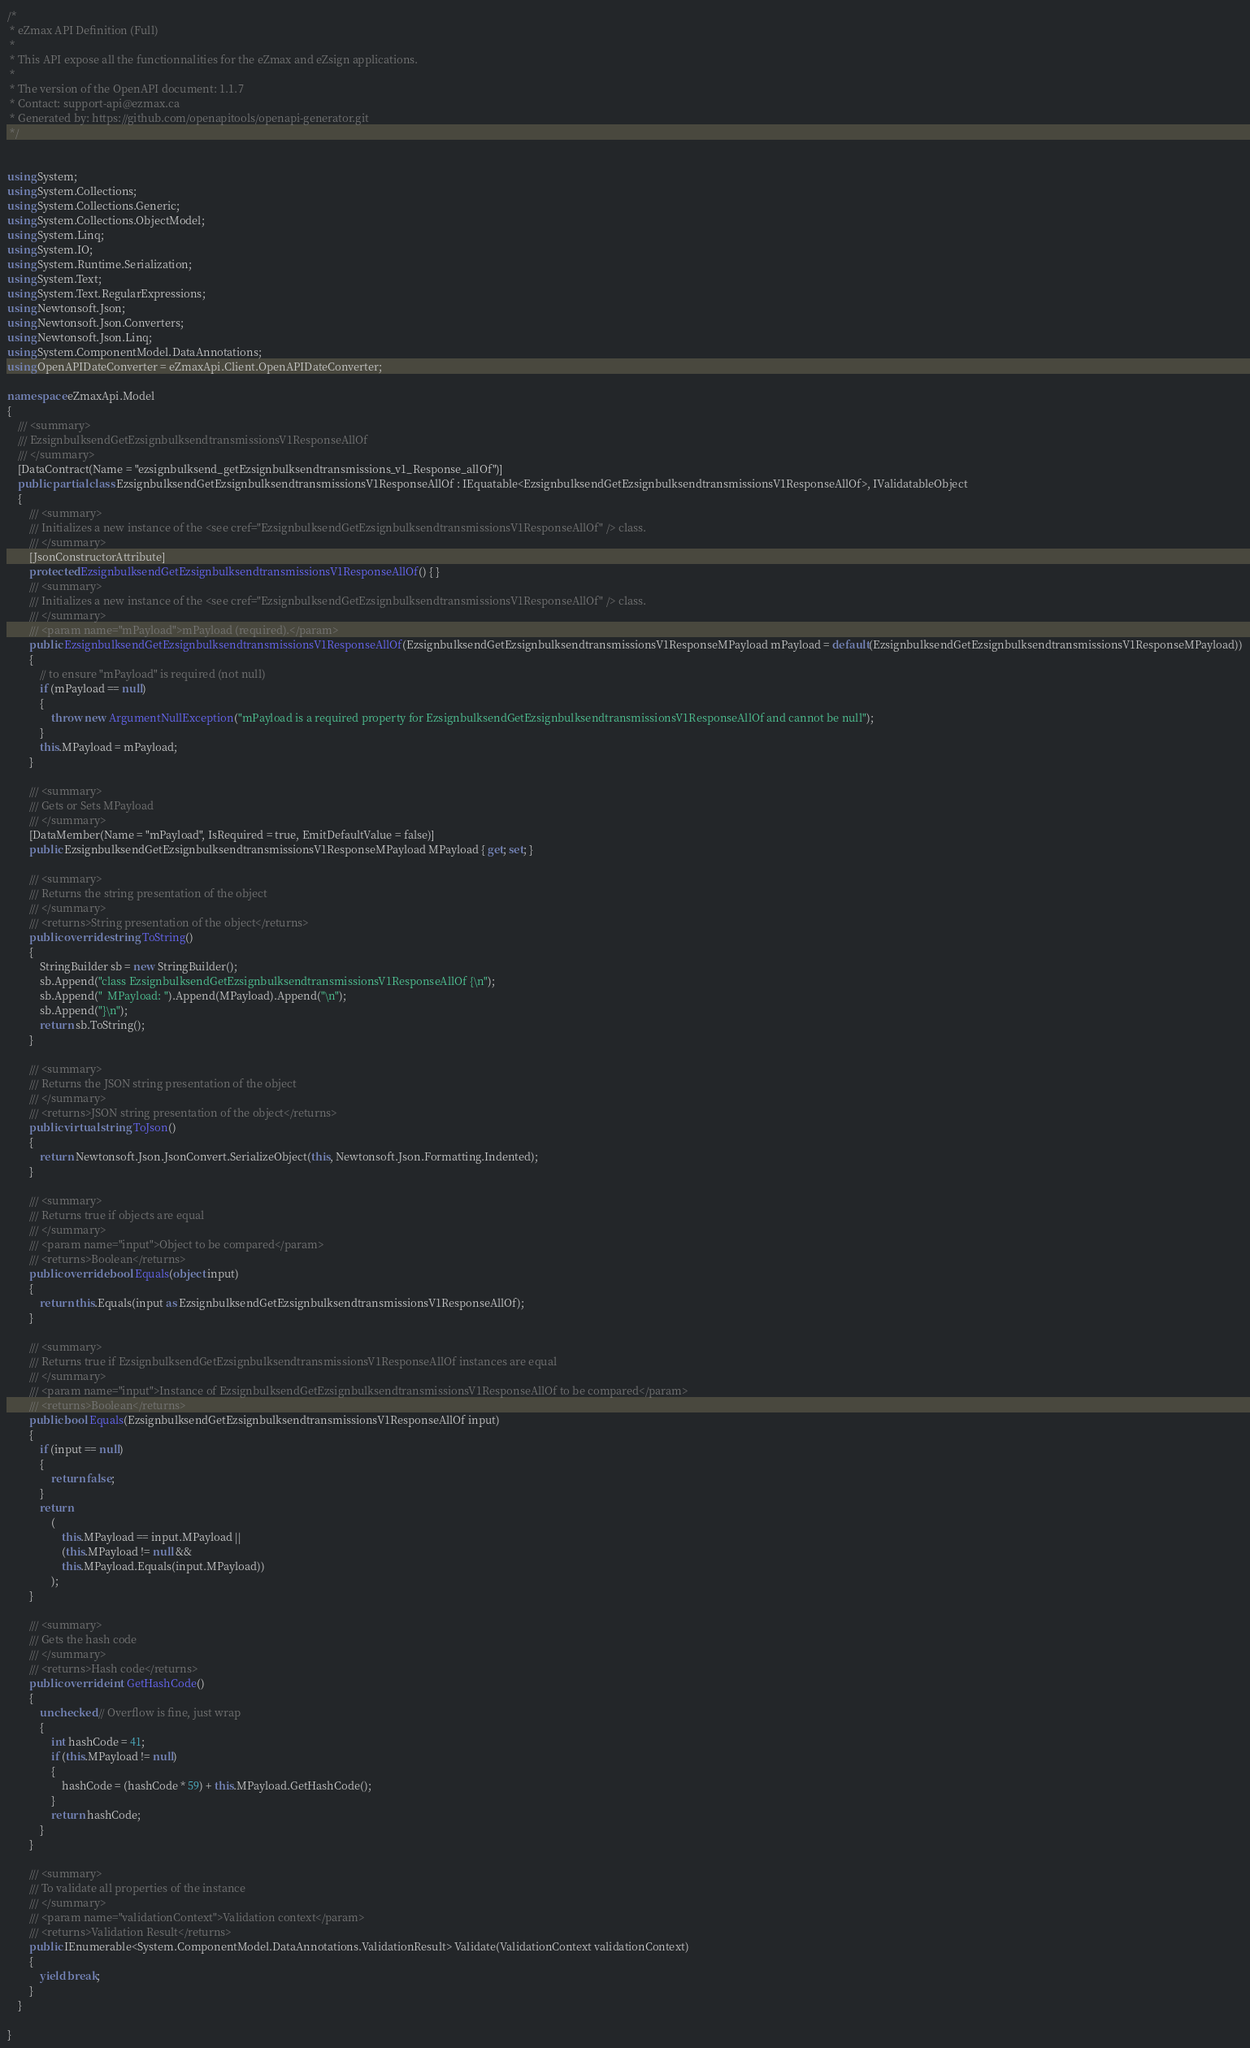Convert code to text. <code><loc_0><loc_0><loc_500><loc_500><_C#_>/*
 * eZmax API Definition (Full)
 *
 * This API expose all the functionnalities for the eZmax and eZsign applications.
 *
 * The version of the OpenAPI document: 1.1.7
 * Contact: support-api@ezmax.ca
 * Generated by: https://github.com/openapitools/openapi-generator.git
 */


using System;
using System.Collections;
using System.Collections.Generic;
using System.Collections.ObjectModel;
using System.Linq;
using System.IO;
using System.Runtime.Serialization;
using System.Text;
using System.Text.RegularExpressions;
using Newtonsoft.Json;
using Newtonsoft.Json.Converters;
using Newtonsoft.Json.Linq;
using System.ComponentModel.DataAnnotations;
using OpenAPIDateConverter = eZmaxApi.Client.OpenAPIDateConverter;

namespace eZmaxApi.Model
{
    /// <summary>
    /// EzsignbulksendGetEzsignbulksendtransmissionsV1ResponseAllOf
    /// </summary>
    [DataContract(Name = "ezsignbulksend_getEzsignbulksendtransmissions_v1_Response_allOf")]
    public partial class EzsignbulksendGetEzsignbulksendtransmissionsV1ResponseAllOf : IEquatable<EzsignbulksendGetEzsignbulksendtransmissionsV1ResponseAllOf>, IValidatableObject
    {
        /// <summary>
        /// Initializes a new instance of the <see cref="EzsignbulksendGetEzsignbulksendtransmissionsV1ResponseAllOf" /> class.
        /// </summary>
        [JsonConstructorAttribute]
        protected EzsignbulksendGetEzsignbulksendtransmissionsV1ResponseAllOf() { }
        /// <summary>
        /// Initializes a new instance of the <see cref="EzsignbulksendGetEzsignbulksendtransmissionsV1ResponseAllOf" /> class.
        /// </summary>
        /// <param name="mPayload">mPayload (required).</param>
        public EzsignbulksendGetEzsignbulksendtransmissionsV1ResponseAllOf(EzsignbulksendGetEzsignbulksendtransmissionsV1ResponseMPayload mPayload = default(EzsignbulksendGetEzsignbulksendtransmissionsV1ResponseMPayload))
        {
            // to ensure "mPayload" is required (not null)
            if (mPayload == null)
            {
                throw new ArgumentNullException("mPayload is a required property for EzsignbulksendGetEzsignbulksendtransmissionsV1ResponseAllOf and cannot be null");
            }
            this.MPayload = mPayload;
        }

        /// <summary>
        /// Gets or Sets MPayload
        /// </summary>
        [DataMember(Name = "mPayload", IsRequired = true, EmitDefaultValue = false)]
        public EzsignbulksendGetEzsignbulksendtransmissionsV1ResponseMPayload MPayload { get; set; }

        /// <summary>
        /// Returns the string presentation of the object
        /// </summary>
        /// <returns>String presentation of the object</returns>
        public override string ToString()
        {
            StringBuilder sb = new StringBuilder();
            sb.Append("class EzsignbulksendGetEzsignbulksendtransmissionsV1ResponseAllOf {\n");
            sb.Append("  MPayload: ").Append(MPayload).Append("\n");
            sb.Append("}\n");
            return sb.ToString();
        }

        /// <summary>
        /// Returns the JSON string presentation of the object
        /// </summary>
        /// <returns>JSON string presentation of the object</returns>
        public virtual string ToJson()
        {
            return Newtonsoft.Json.JsonConvert.SerializeObject(this, Newtonsoft.Json.Formatting.Indented);
        }

        /// <summary>
        /// Returns true if objects are equal
        /// </summary>
        /// <param name="input">Object to be compared</param>
        /// <returns>Boolean</returns>
        public override bool Equals(object input)
        {
            return this.Equals(input as EzsignbulksendGetEzsignbulksendtransmissionsV1ResponseAllOf);
        }

        /// <summary>
        /// Returns true if EzsignbulksendGetEzsignbulksendtransmissionsV1ResponseAllOf instances are equal
        /// </summary>
        /// <param name="input">Instance of EzsignbulksendGetEzsignbulksendtransmissionsV1ResponseAllOf to be compared</param>
        /// <returns>Boolean</returns>
        public bool Equals(EzsignbulksendGetEzsignbulksendtransmissionsV1ResponseAllOf input)
        {
            if (input == null)
            {
                return false;
            }
            return 
                (
                    this.MPayload == input.MPayload ||
                    (this.MPayload != null &&
                    this.MPayload.Equals(input.MPayload))
                );
        }

        /// <summary>
        /// Gets the hash code
        /// </summary>
        /// <returns>Hash code</returns>
        public override int GetHashCode()
        {
            unchecked // Overflow is fine, just wrap
            {
                int hashCode = 41;
                if (this.MPayload != null)
                {
                    hashCode = (hashCode * 59) + this.MPayload.GetHashCode();
                }
                return hashCode;
            }
        }

        /// <summary>
        /// To validate all properties of the instance
        /// </summary>
        /// <param name="validationContext">Validation context</param>
        /// <returns>Validation Result</returns>
        public IEnumerable<System.ComponentModel.DataAnnotations.ValidationResult> Validate(ValidationContext validationContext)
        {
            yield break;
        }
    }

}
</code> 